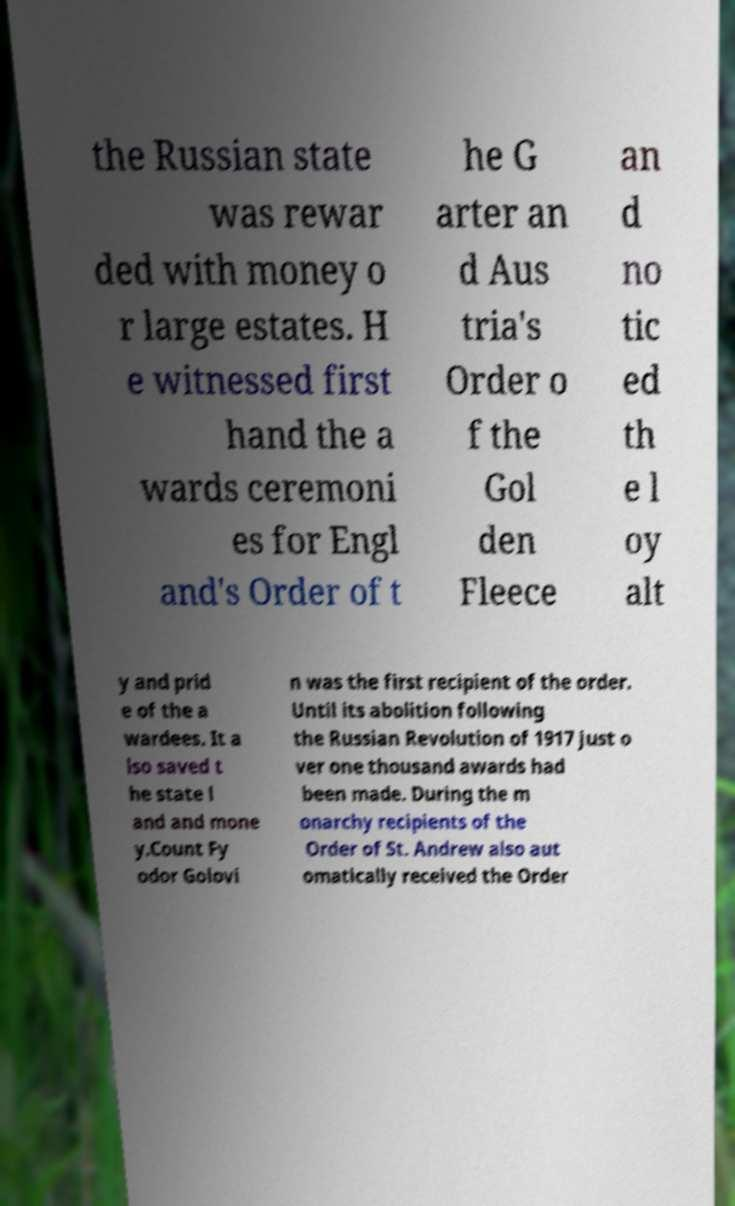Please identify and transcribe the text found in this image. the Russian state was rewar ded with money o r large estates. H e witnessed first hand the a wards ceremoni es for Engl and's Order of t he G arter an d Aus tria's Order o f the Gol den Fleece an d no tic ed th e l oy alt y and prid e of the a wardees. It a lso saved t he state l and and mone y.Count Fy odor Golovi n was the first recipient of the order. Until its abolition following the Russian Revolution of 1917 just o ver one thousand awards had been made. During the m onarchy recipients of the Order of St. Andrew also aut omatically received the Order 